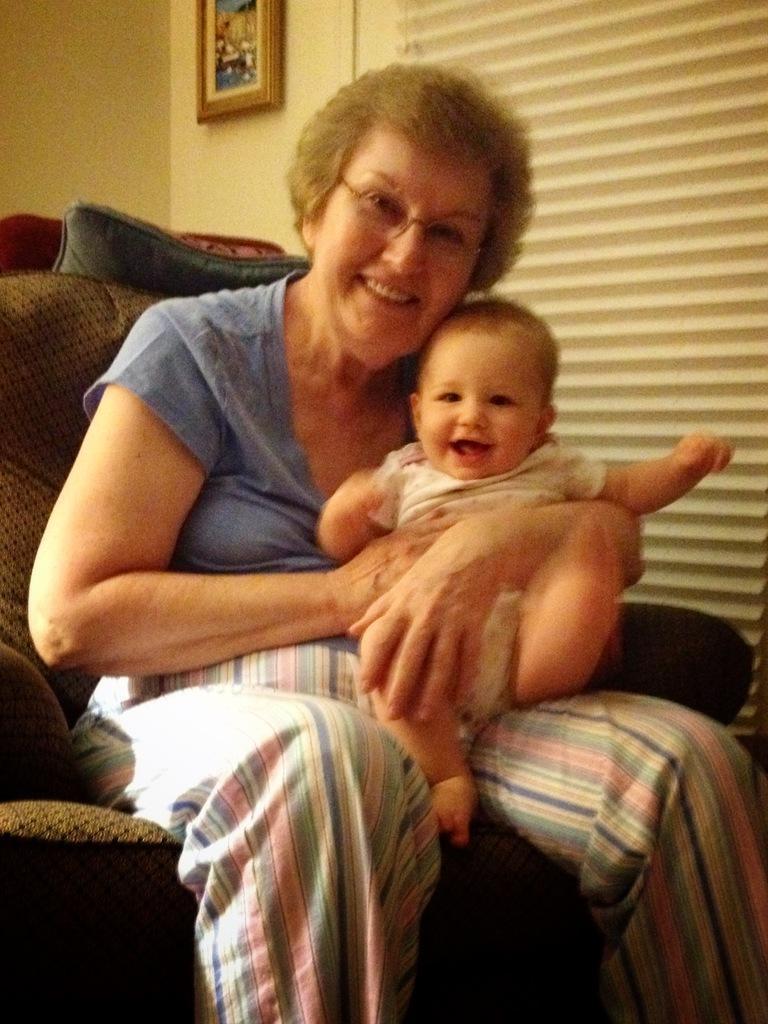Please provide a concise description of this image. In this image there is a woman, she is holding baby in her hands and sitting in a sofa, in the background there is a wall to that wall there is a photo frame. 